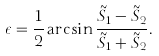<formula> <loc_0><loc_0><loc_500><loc_500>\epsilon = \frac { 1 } { 2 } \arcsin \frac { \tilde { S } _ { 1 } - \tilde { S } _ { 2 } } { \tilde { S } _ { 1 } + \tilde { S } _ { 2 } } .</formula> 